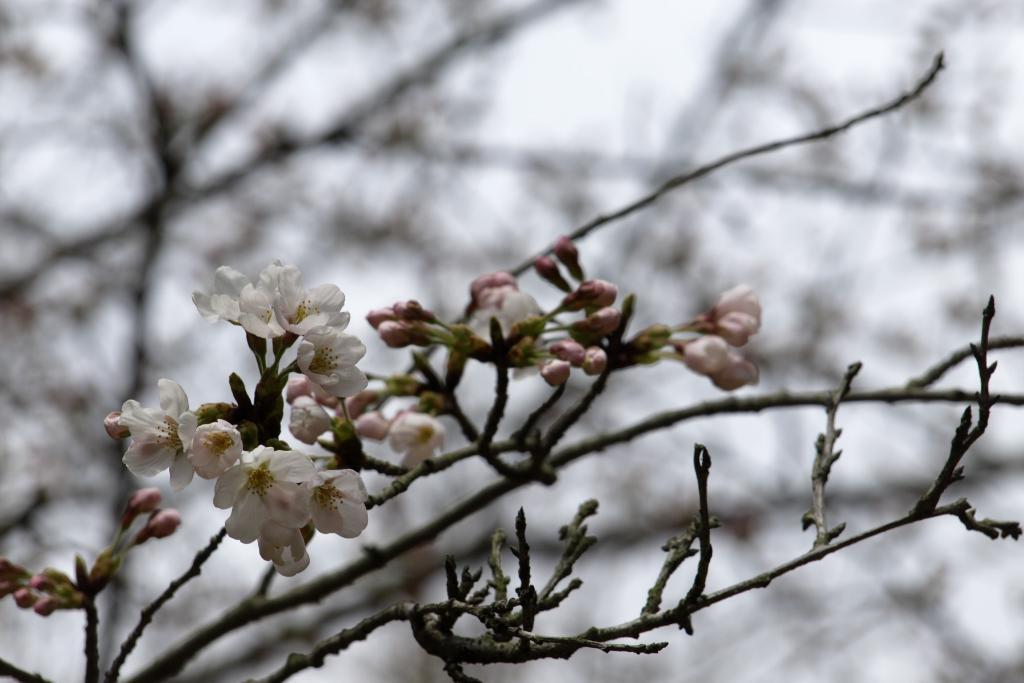What type of flowers are present in the image? There are white color flowers in the image. Can you describe any specific features of the flowers? Yes, there are buds on a stem in the image. What is the appearance of the background in the image? The background of the image is blurred. Can you tell me how many volleyballs are visible in the image? There are no volleyballs present in the image. What type of sail can be seen in the image? There is no sail present in the image. 